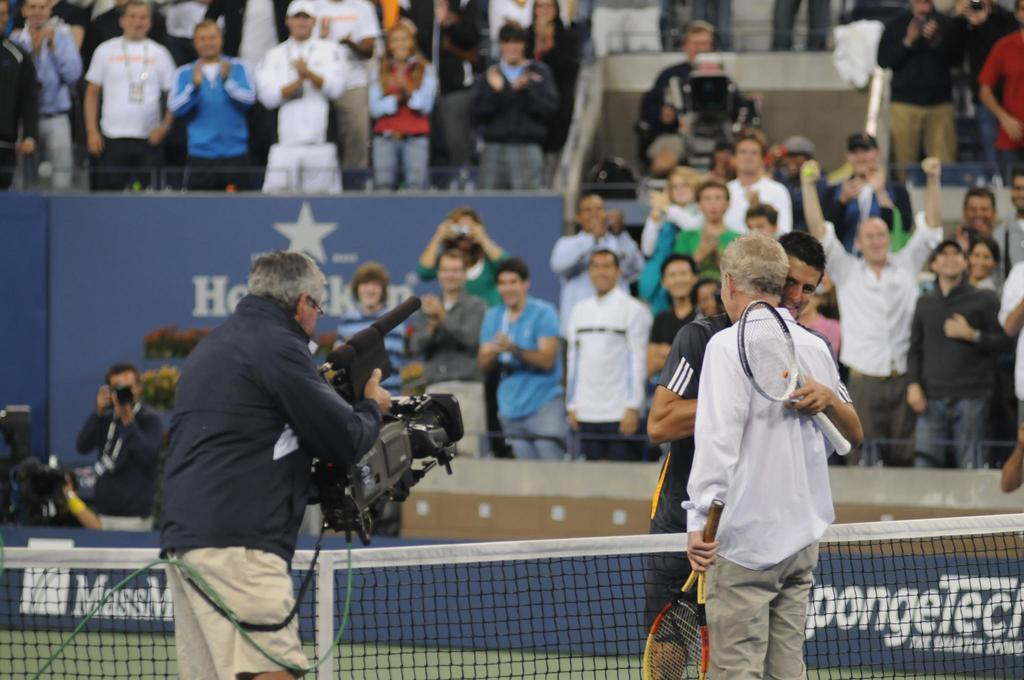<image>
Provide a brief description of the given image. Heineken ad in the background of a tennis match. 